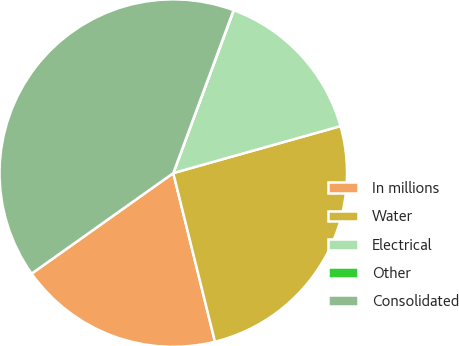Convert chart to OTSL. <chart><loc_0><loc_0><loc_500><loc_500><pie_chart><fcel>In millions<fcel>Water<fcel>Electrical<fcel>Other<fcel>Consolidated<nl><fcel>19.03%<fcel>25.5%<fcel>14.98%<fcel>0.02%<fcel>40.46%<nl></chart> 